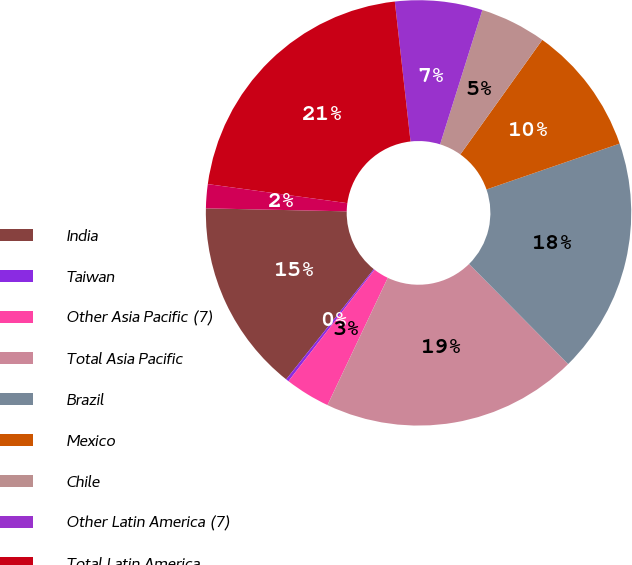<chart> <loc_0><loc_0><loc_500><loc_500><pie_chart><fcel>India<fcel>Taiwan<fcel>Other Asia Pacific (7)<fcel>Total Asia Pacific<fcel>Brazil<fcel>Mexico<fcel>Chile<fcel>Other Latin America (7)<fcel>Total Latin America<fcel>Other Middle East and Africa<nl><fcel>14.65%<fcel>0.22%<fcel>3.43%<fcel>19.46%<fcel>17.86%<fcel>9.84%<fcel>5.03%<fcel>6.63%<fcel>21.06%<fcel>1.82%<nl></chart> 